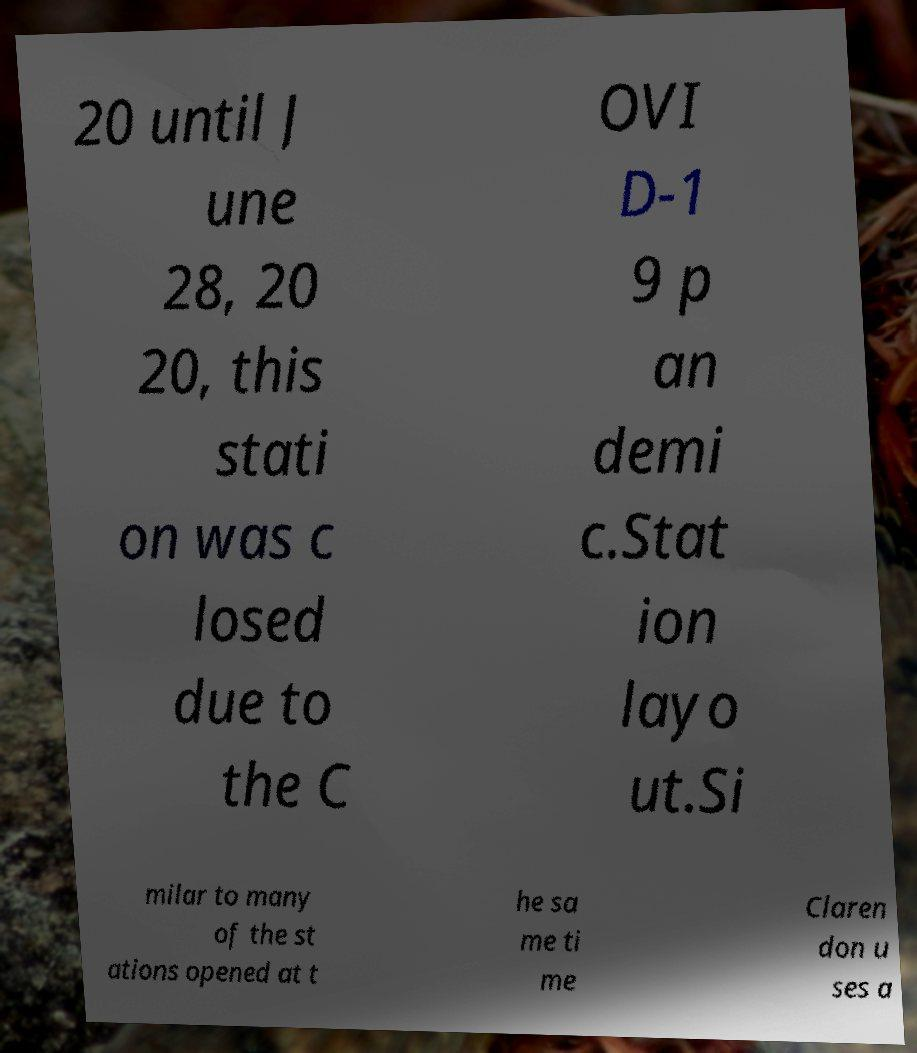Please identify and transcribe the text found in this image. 20 until J une 28, 20 20, this stati on was c losed due to the C OVI D-1 9 p an demi c.Stat ion layo ut.Si milar to many of the st ations opened at t he sa me ti me Claren don u ses a 